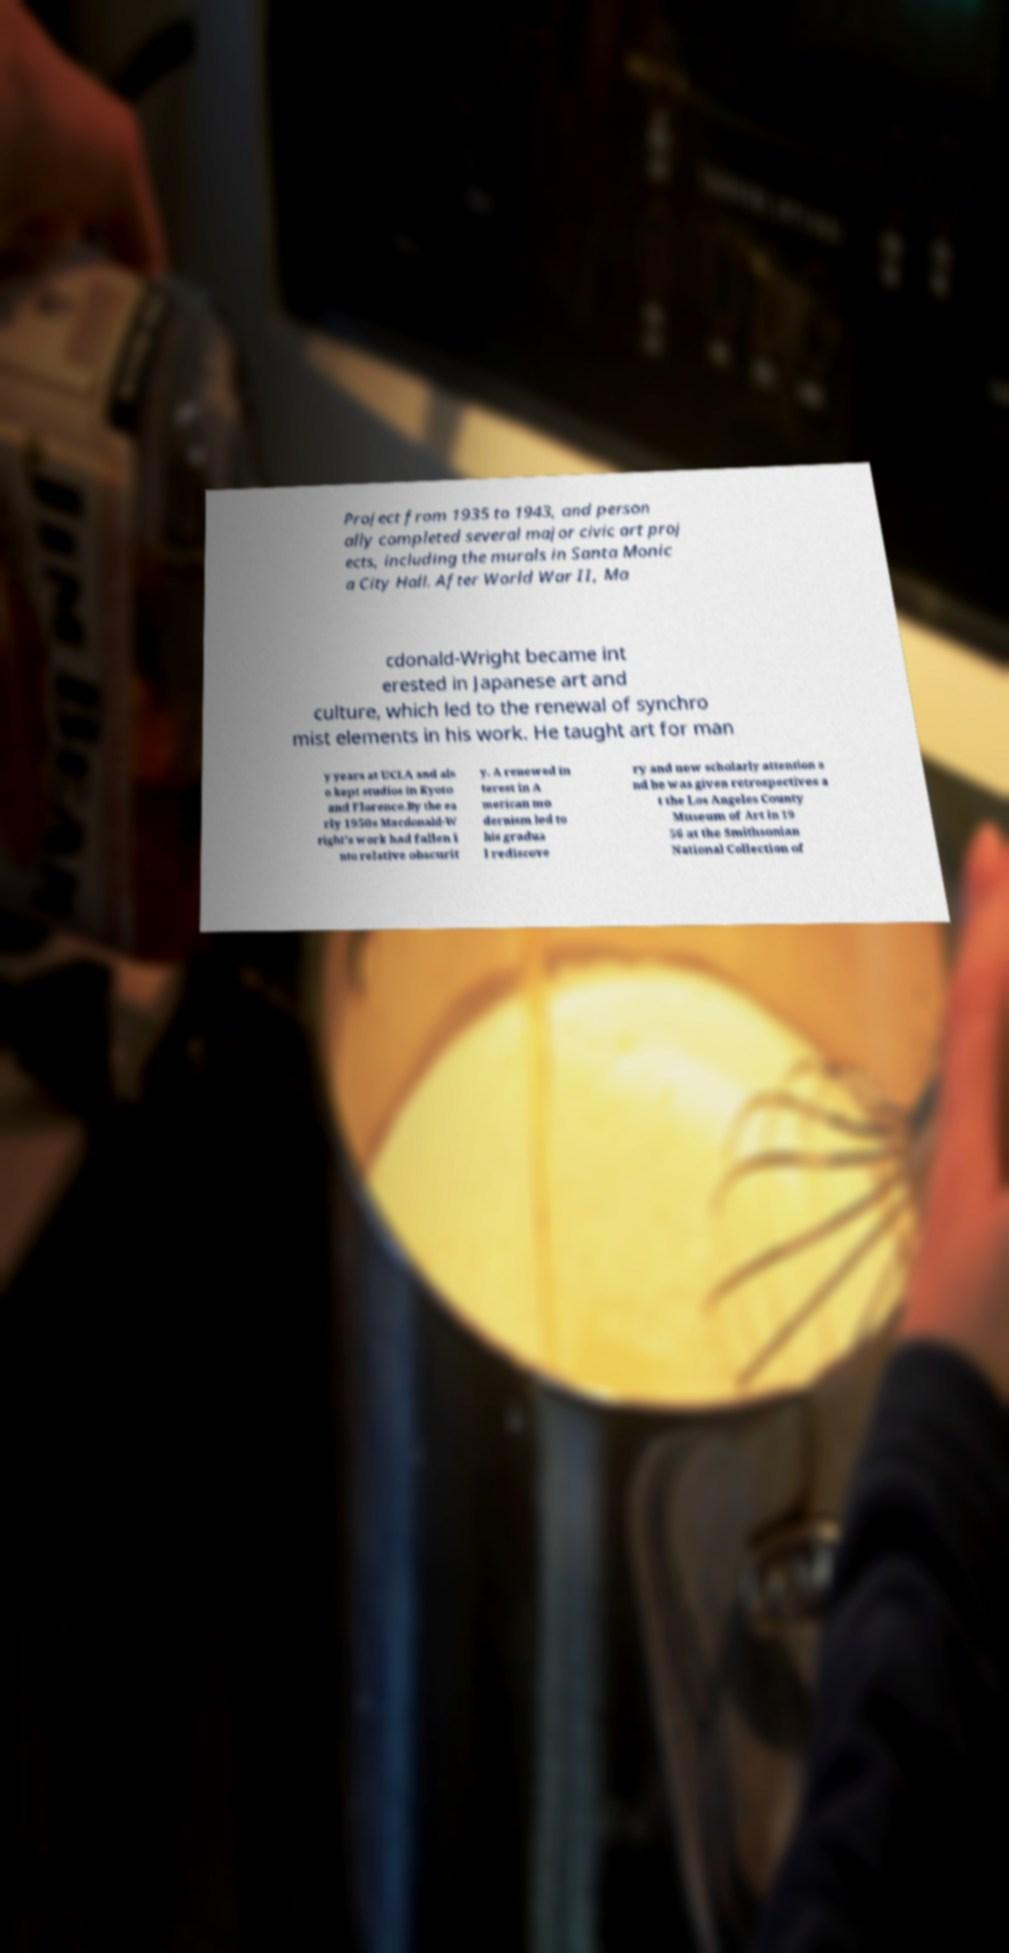Please read and relay the text visible in this image. What does it say? Project from 1935 to 1943, and person ally completed several major civic art proj ects, including the murals in Santa Monic a City Hall. After World War II, Ma cdonald-Wright became int erested in Japanese art and culture, which led to the renewal of synchro mist elements in his work. He taught art for man y years at UCLA and als o kept studios in Kyoto and Florence.By the ea rly 1950s Macdonald-W right's work had fallen i nto relative obscurit y. A renewed in terest in A merican mo dernism led to his gradua l rediscove ry and new scholarly attention a nd he was given retrospectives a t the Los Angeles County Museum of Art in 19 56 at the Smithsonian National Collection of 